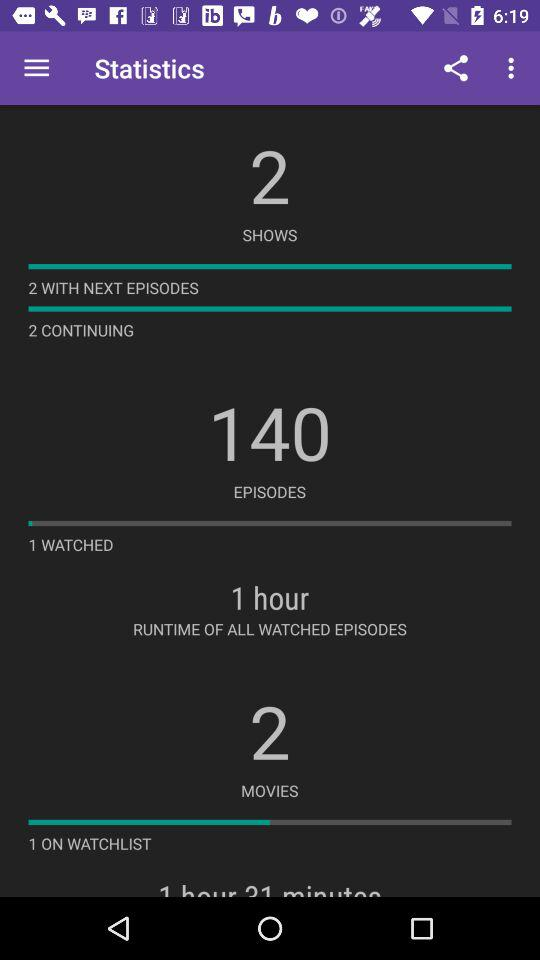What is the number of episodes? The number of episodes is 140. 